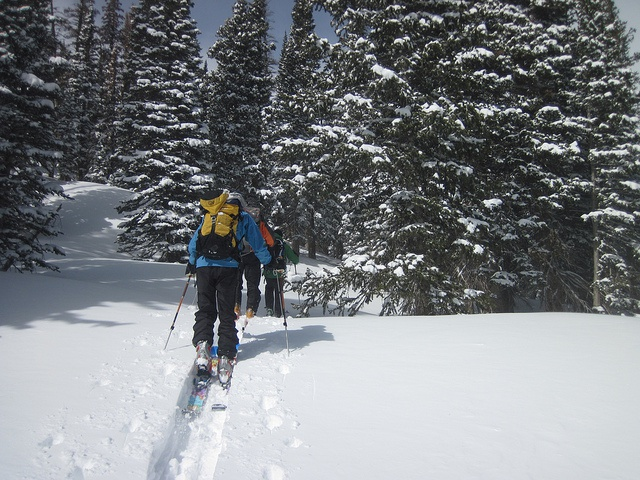Describe the objects in this image and their specific colors. I can see people in gray, black, lightgray, and navy tones, backpack in gray, black, and olive tones, people in gray, black, and darkgreen tones, skis in gray, lightgray, and darkgray tones, and backpack in gray, black, and maroon tones in this image. 